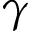Convert formula to latex. <formula><loc_0><loc_0><loc_500><loc_500>\gamma</formula> 